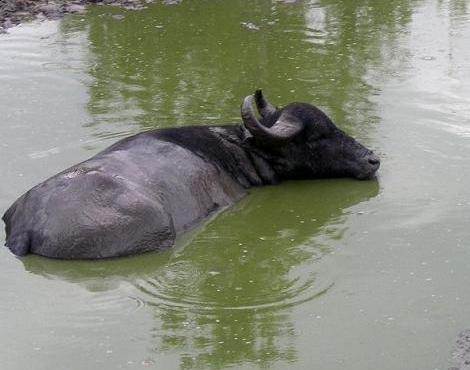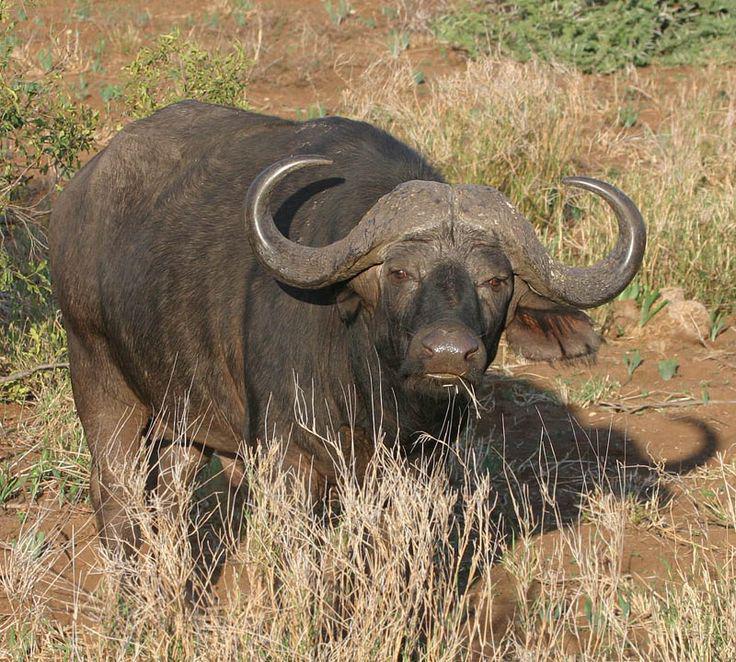The first image is the image on the left, the second image is the image on the right. For the images shown, is this caption "At least 1 cattle is submerged to the shoulder." true? Answer yes or no. Yes. 